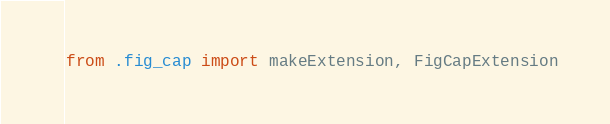<code> <loc_0><loc_0><loc_500><loc_500><_Python_>from .fig_cap import makeExtension, FigCapExtension
</code> 